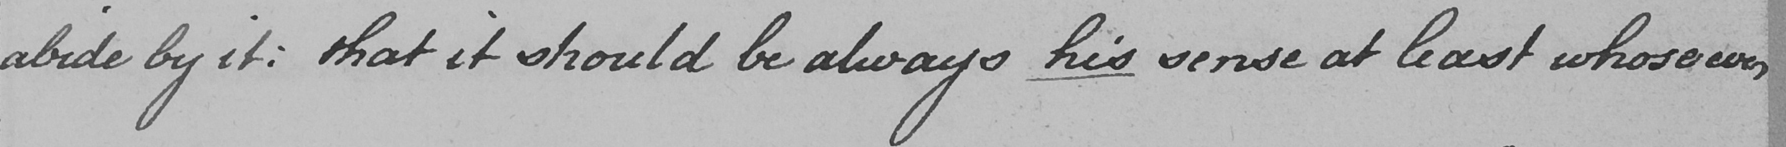What does this handwritten line say? abide by it :  that it should be always his sense at least whosoever 